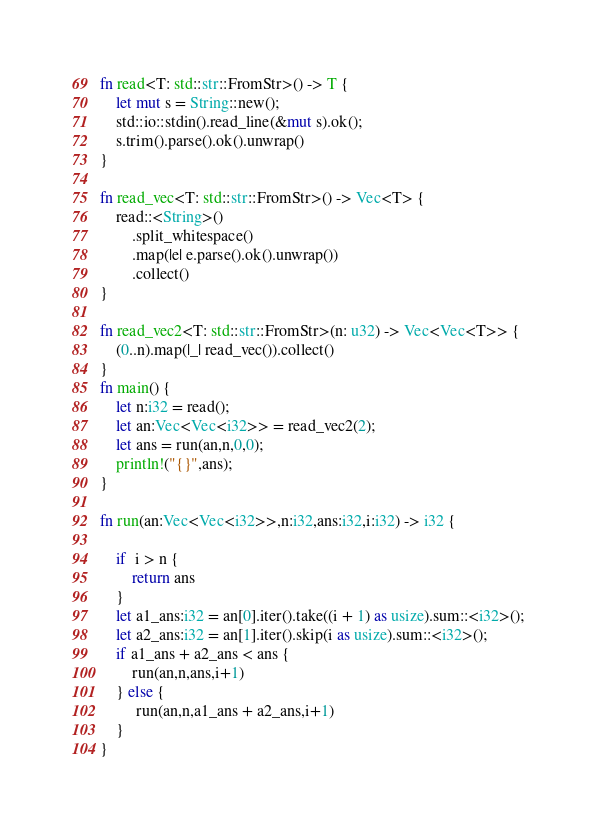Convert code to text. <code><loc_0><loc_0><loc_500><loc_500><_Rust_>fn read<T: std::str::FromStr>() -> T {
    let mut s = String::new();
    std::io::stdin().read_line(&mut s).ok();
    s.trim().parse().ok().unwrap()
}

fn read_vec<T: std::str::FromStr>() -> Vec<T> {
    read::<String>()
        .split_whitespace()
        .map(|e| e.parse().ok().unwrap())
        .collect()
}

fn read_vec2<T: std::str::FromStr>(n: u32) -> Vec<Vec<T>> {
    (0..n).map(|_| read_vec()).collect()
}
fn main() {
    let n:i32 = read();
    let an:Vec<Vec<i32>> = read_vec2(2);
    let ans = run(an,n,0,0);
    println!("{}",ans);
}

fn run(an:Vec<Vec<i32>>,n:i32,ans:i32,i:i32) -> i32 {
   
    if  i > n {
        return ans 
    }
    let a1_ans:i32 = an[0].iter().take((i + 1) as usize).sum::<i32>();
    let a2_ans:i32 = an[1].iter().skip(i as usize).sum::<i32>();
    if a1_ans + a2_ans < ans {
        run(an,n,ans,i+1)
    } else {
         run(an,n,a1_ans + a2_ans,i+1)
    }
}</code> 